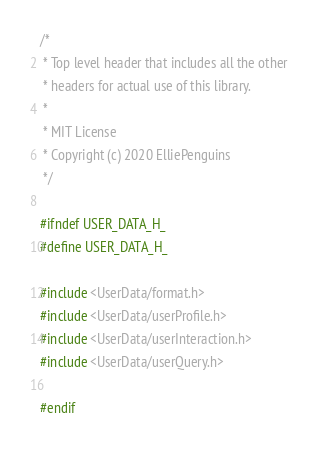Convert code to text. <code><loc_0><loc_0><loc_500><loc_500><_C_>/* 
 * Top level header that includes all the other
 * headers for actual use of this library.
 *
 * MIT License
 * Copyright (c) 2020 ElliePenguins
 */

#ifndef USER_DATA_H_
#define USER_DATA_H_

#include <UserData/format.h>
#include <UserData/userProfile.h>
#include <UserData/userInteraction.h>
#include <UserData/userQuery.h>

#endif 

</code> 